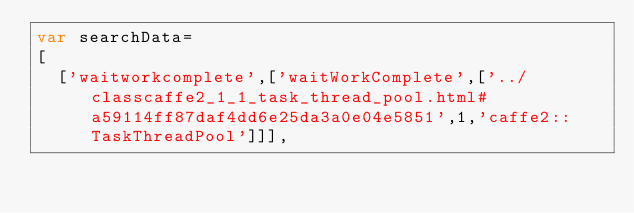<code> <loc_0><loc_0><loc_500><loc_500><_JavaScript_>var searchData=
[
  ['waitworkcomplete',['waitWorkComplete',['../classcaffe2_1_1_task_thread_pool.html#a59114ff87daf4dd6e25da3a0e04e5851',1,'caffe2::TaskThreadPool']]],</code> 